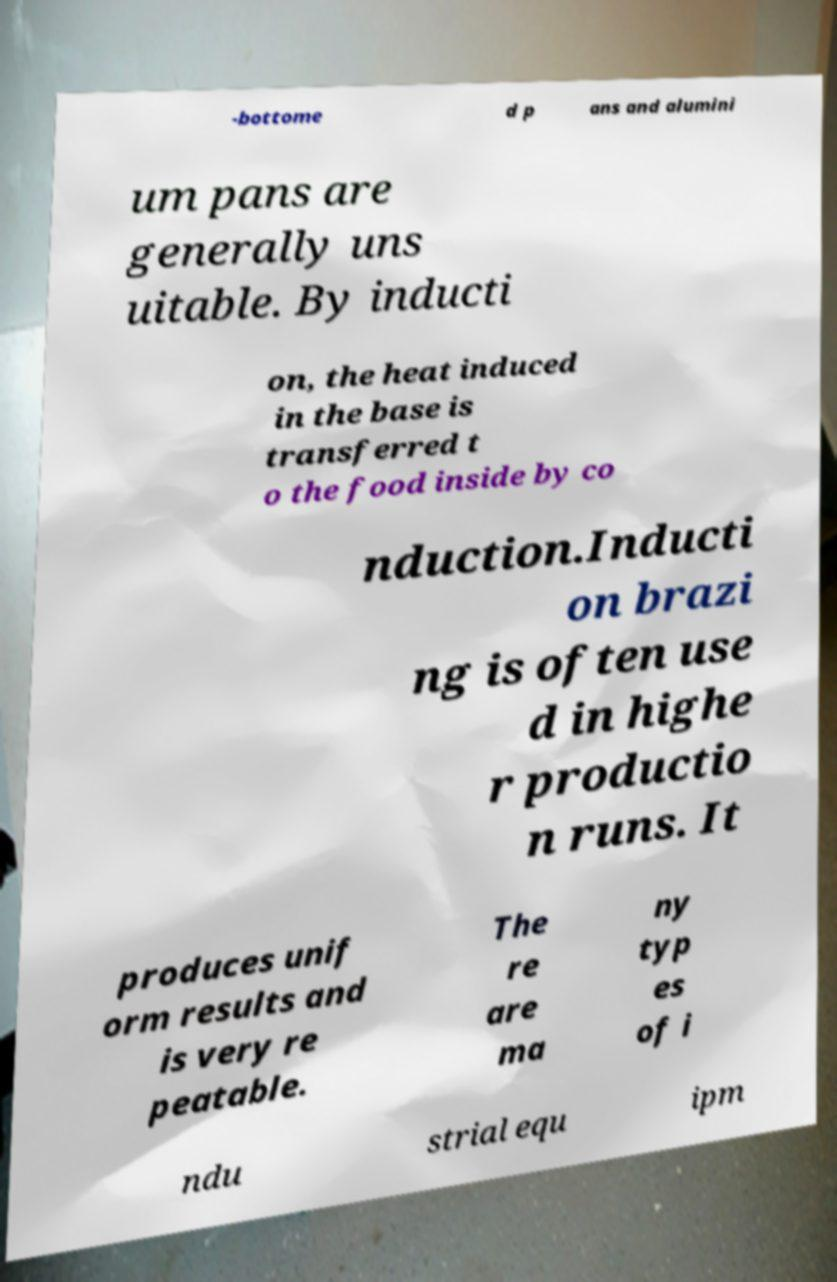What messages or text are displayed in this image? I need them in a readable, typed format. -bottome d p ans and alumini um pans are generally uns uitable. By inducti on, the heat induced in the base is transferred t o the food inside by co nduction.Inducti on brazi ng is often use d in highe r productio n runs. It produces unif orm results and is very re peatable. The re are ma ny typ es of i ndu strial equ ipm 